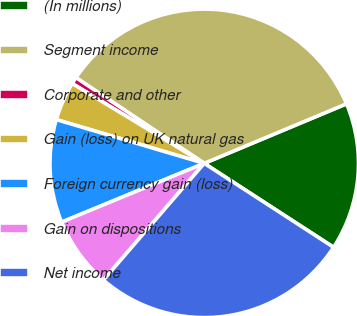Convert chart to OTSL. <chart><loc_0><loc_0><loc_500><loc_500><pie_chart><fcel>(In millions)<fcel>Segment income<fcel>Corporate and other<fcel>Gain (loss) on UK natural gas<fcel>Foreign currency gain (loss)<fcel>Gain on dispositions<fcel>Net income<nl><fcel>15.47%<fcel>34.32%<fcel>0.72%<fcel>4.08%<fcel>10.8%<fcel>7.44%<fcel>27.18%<nl></chart> 